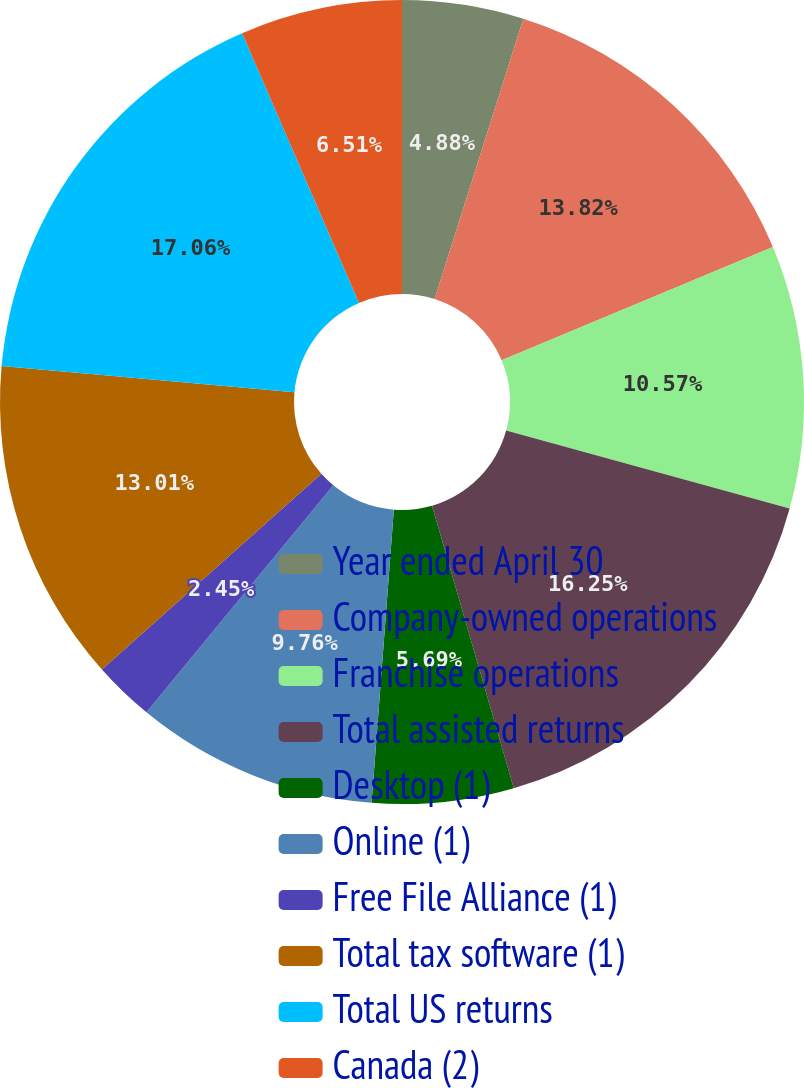<chart> <loc_0><loc_0><loc_500><loc_500><pie_chart><fcel>Year ended April 30<fcel>Company-owned operations<fcel>Franchise operations<fcel>Total assisted returns<fcel>Desktop (1)<fcel>Online (1)<fcel>Free File Alliance (1)<fcel>Total tax software (1)<fcel>Total US returns<fcel>Canada (2)<nl><fcel>4.88%<fcel>13.82%<fcel>10.57%<fcel>16.25%<fcel>5.69%<fcel>9.76%<fcel>2.45%<fcel>13.01%<fcel>17.07%<fcel>6.51%<nl></chart> 